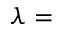Convert formula to latex. <formula><loc_0><loc_0><loc_500><loc_500>\lambda =</formula> 